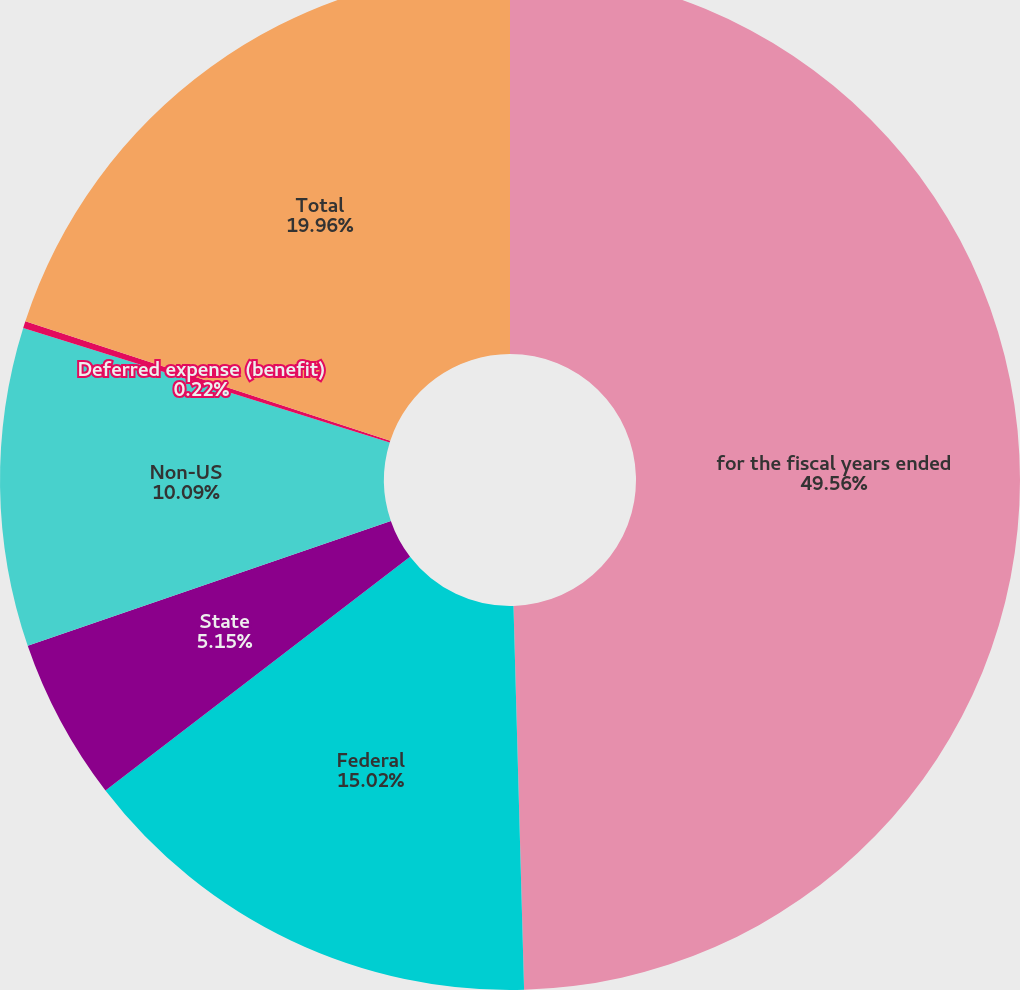Convert chart. <chart><loc_0><loc_0><loc_500><loc_500><pie_chart><fcel>for the fiscal years ended<fcel>Federal<fcel>State<fcel>Non-US<fcel>Deferred expense (benefit)<fcel>Total<nl><fcel>49.56%<fcel>15.02%<fcel>5.15%<fcel>10.09%<fcel>0.22%<fcel>19.96%<nl></chart> 